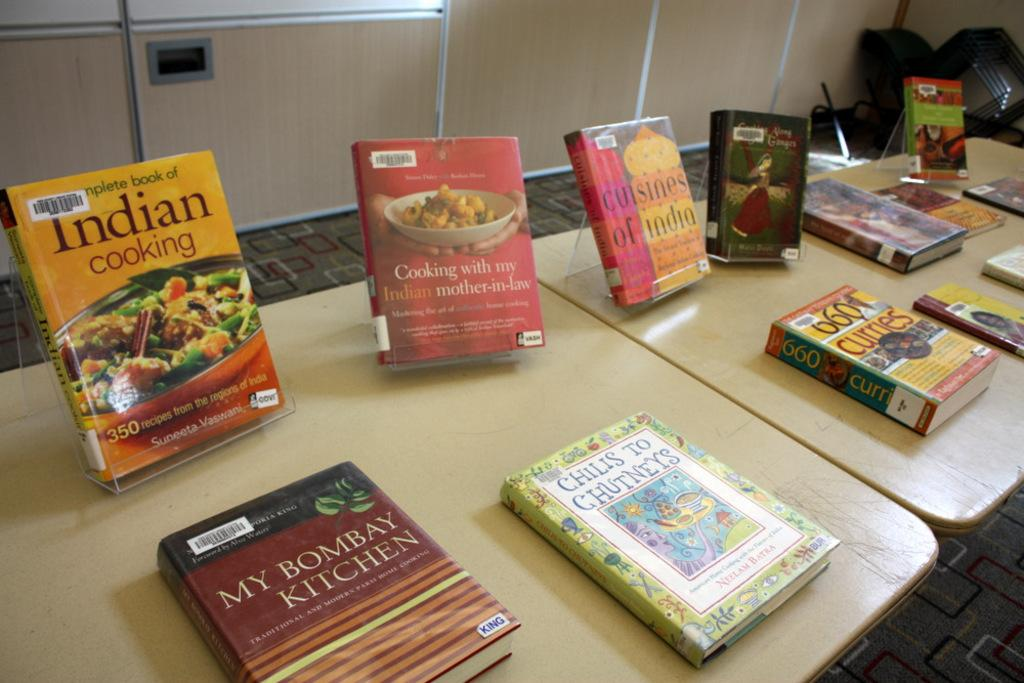<image>
Provide a brief description of the given image. Numerous cookbooks sitting on tables with one called My Bombay Kitchen 